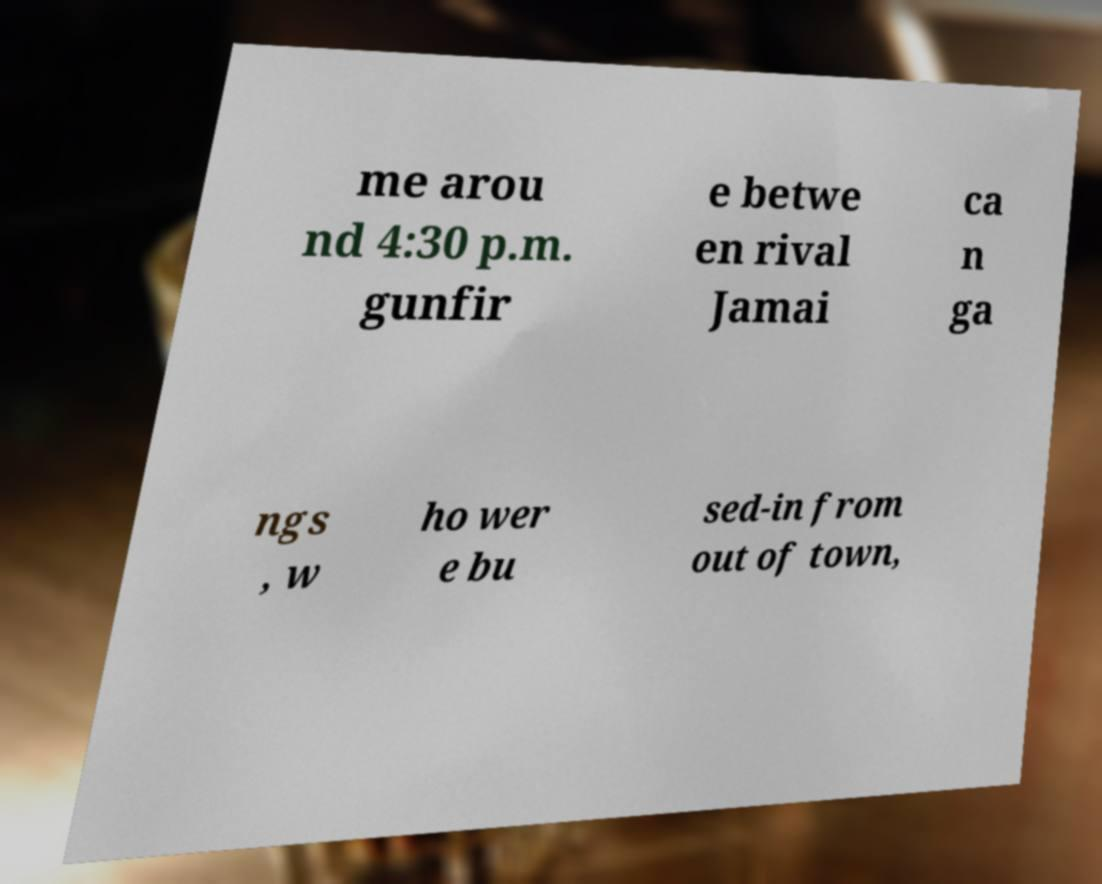Please identify and transcribe the text found in this image. me arou nd 4:30 p.m. gunfir e betwe en rival Jamai ca n ga ngs , w ho wer e bu sed-in from out of town, 